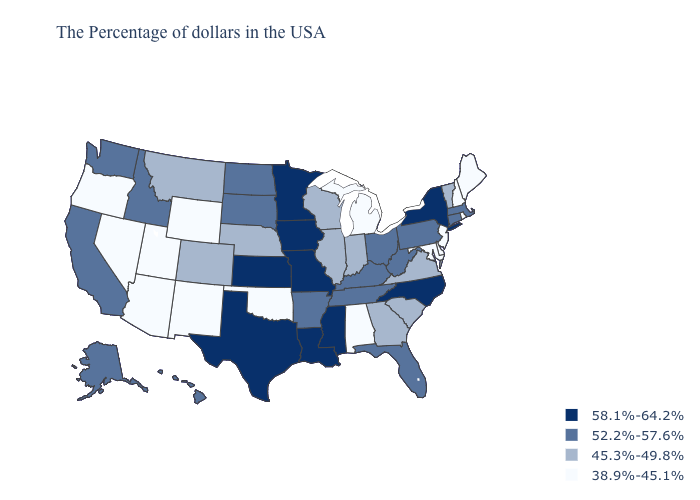What is the value of New York?
Keep it brief. 58.1%-64.2%. Does Ohio have a higher value than Iowa?
Short answer required. No. Name the states that have a value in the range 58.1%-64.2%?
Keep it brief. New York, North Carolina, Mississippi, Louisiana, Missouri, Minnesota, Iowa, Kansas, Texas. What is the value of Maryland?
Answer briefly. 38.9%-45.1%. What is the highest value in the USA?
Write a very short answer. 58.1%-64.2%. Does Colorado have the same value as Mississippi?
Be succinct. No. What is the value of Maryland?
Be succinct. 38.9%-45.1%. Which states have the lowest value in the USA?
Give a very brief answer. Maine, Rhode Island, New Hampshire, New Jersey, Delaware, Maryland, Michigan, Alabama, Oklahoma, Wyoming, New Mexico, Utah, Arizona, Nevada, Oregon. Does Minnesota have the lowest value in the USA?
Be succinct. No. Name the states that have a value in the range 52.2%-57.6%?
Answer briefly. Massachusetts, Connecticut, Pennsylvania, West Virginia, Ohio, Florida, Kentucky, Tennessee, Arkansas, South Dakota, North Dakota, Idaho, California, Washington, Alaska, Hawaii. Name the states that have a value in the range 52.2%-57.6%?
Quick response, please. Massachusetts, Connecticut, Pennsylvania, West Virginia, Ohio, Florida, Kentucky, Tennessee, Arkansas, South Dakota, North Dakota, Idaho, California, Washington, Alaska, Hawaii. Does Hawaii have the lowest value in the West?
Quick response, please. No. Which states have the lowest value in the USA?
Short answer required. Maine, Rhode Island, New Hampshire, New Jersey, Delaware, Maryland, Michigan, Alabama, Oklahoma, Wyoming, New Mexico, Utah, Arizona, Nevada, Oregon. Does the first symbol in the legend represent the smallest category?
Write a very short answer. No. 